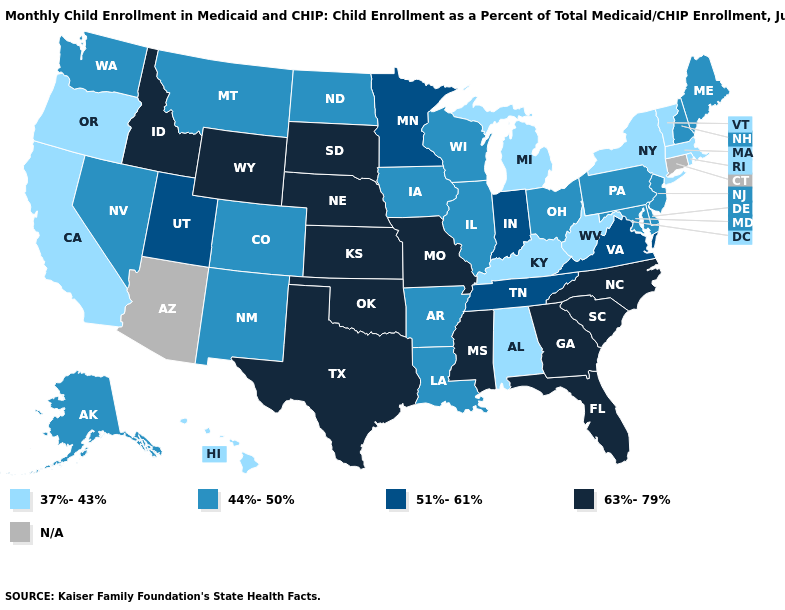Name the states that have a value in the range 51%-61%?
Write a very short answer. Indiana, Minnesota, Tennessee, Utah, Virginia. Among the states that border Louisiana , which have the highest value?
Keep it brief. Mississippi, Texas. What is the value of Tennessee?
Give a very brief answer. 51%-61%. Name the states that have a value in the range 44%-50%?
Give a very brief answer. Alaska, Arkansas, Colorado, Delaware, Illinois, Iowa, Louisiana, Maine, Maryland, Montana, Nevada, New Hampshire, New Jersey, New Mexico, North Dakota, Ohio, Pennsylvania, Washington, Wisconsin. What is the value of Idaho?
Concise answer only. 63%-79%. Does Maine have the highest value in the Northeast?
Give a very brief answer. Yes. Which states have the lowest value in the Northeast?
Concise answer only. Massachusetts, New York, Rhode Island, Vermont. How many symbols are there in the legend?
Answer briefly. 5. Does Kentucky have the lowest value in the USA?
Answer briefly. Yes. Name the states that have a value in the range 63%-79%?
Quick response, please. Florida, Georgia, Idaho, Kansas, Mississippi, Missouri, Nebraska, North Carolina, Oklahoma, South Carolina, South Dakota, Texas, Wyoming. What is the lowest value in states that border Delaware?
Concise answer only. 44%-50%. Among the states that border New Hampshire , which have the highest value?
Write a very short answer. Maine. Name the states that have a value in the range 51%-61%?
Give a very brief answer. Indiana, Minnesota, Tennessee, Utah, Virginia. What is the value of New York?
Quick response, please. 37%-43%. Name the states that have a value in the range 51%-61%?
Concise answer only. Indiana, Minnesota, Tennessee, Utah, Virginia. 